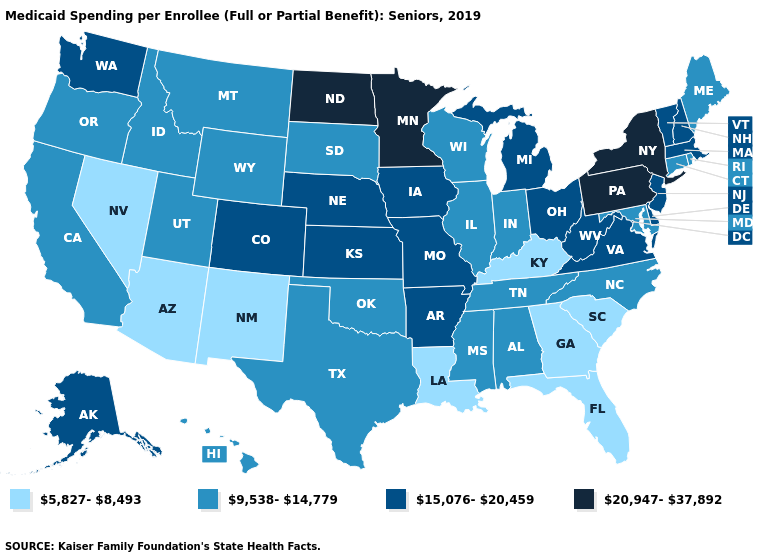Name the states that have a value in the range 20,947-37,892?
Quick response, please. Minnesota, New York, North Dakota, Pennsylvania. Name the states that have a value in the range 5,827-8,493?
Quick response, please. Arizona, Florida, Georgia, Kentucky, Louisiana, Nevada, New Mexico, South Carolina. Among the states that border Virginia , does Kentucky have the lowest value?
Quick response, please. Yes. Does Massachusetts have the highest value in the Northeast?
Write a very short answer. No. What is the highest value in states that border Maine?
Give a very brief answer. 15,076-20,459. What is the value of North Carolina?
Write a very short answer. 9,538-14,779. Among the states that border Idaho , which have the highest value?
Keep it brief. Washington. Name the states that have a value in the range 9,538-14,779?
Give a very brief answer. Alabama, California, Connecticut, Hawaii, Idaho, Illinois, Indiana, Maine, Maryland, Mississippi, Montana, North Carolina, Oklahoma, Oregon, Rhode Island, South Dakota, Tennessee, Texas, Utah, Wisconsin, Wyoming. Name the states that have a value in the range 5,827-8,493?
Keep it brief. Arizona, Florida, Georgia, Kentucky, Louisiana, Nevada, New Mexico, South Carolina. Which states have the lowest value in the West?
Short answer required. Arizona, Nevada, New Mexico. What is the value of Wyoming?
Answer briefly. 9,538-14,779. Does Florida have the lowest value in the USA?
Answer briefly. Yes. Is the legend a continuous bar?
Concise answer only. No. What is the value of North Carolina?
Keep it brief. 9,538-14,779. Name the states that have a value in the range 5,827-8,493?
Answer briefly. Arizona, Florida, Georgia, Kentucky, Louisiana, Nevada, New Mexico, South Carolina. 